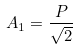<formula> <loc_0><loc_0><loc_500><loc_500>A _ { 1 } = \frac { P } { \sqrt { 2 } }</formula> 